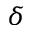<formula> <loc_0><loc_0><loc_500><loc_500>\delta</formula> 